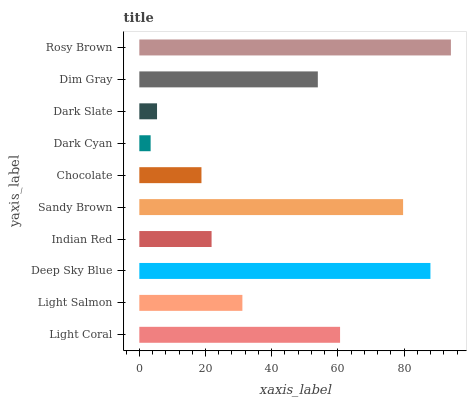Is Dark Cyan the minimum?
Answer yes or no. Yes. Is Rosy Brown the maximum?
Answer yes or no. Yes. Is Light Salmon the minimum?
Answer yes or no. No. Is Light Salmon the maximum?
Answer yes or no. No. Is Light Coral greater than Light Salmon?
Answer yes or no. Yes. Is Light Salmon less than Light Coral?
Answer yes or no. Yes. Is Light Salmon greater than Light Coral?
Answer yes or no. No. Is Light Coral less than Light Salmon?
Answer yes or no. No. Is Dim Gray the high median?
Answer yes or no. Yes. Is Light Salmon the low median?
Answer yes or no. Yes. Is Dark Slate the high median?
Answer yes or no. No. Is Dark Cyan the low median?
Answer yes or no. No. 